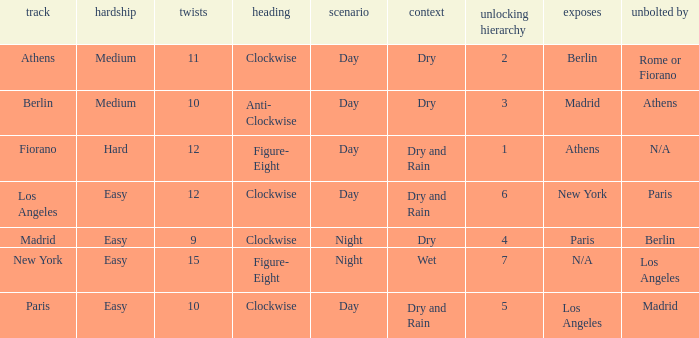What is the difficulty of the athens circuit? Medium. Give me the full table as a dictionary. {'header': ['track', 'hardship', 'twists', 'heading', 'scenario', 'context', 'unlocking hierarchy', 'exposes', 'unbolted by'], 'rows': [['Athens', 'Medium', '11', 'Clockwise', 'Day', 'Dry', '2', 'Berlin', 'Rome or Fiorano'], ['Berlin', 'Medium', '10', 'Anti- Clockwise', 'Day', 'Dry', '3', 'Madrid', 'Athens'], ['Fiorano', 'Hard', '12', 'Figure- Eight', 'Day', 'Dry and Rain', '1', 'Athens', 'N/A'], ['Los Angeles', 'Easy', '12', 'Clockwise', 'Day', 'Dry and Rain', '6', 'New York', 'Paris'], ['Madrid', 'Easy', '9', 'Clockwise', 'Night', 'Dry', '4', 'Paris', 'Berlin'], ['New York', 'Easy', '15', 'Figure- Eight', 'Night', 'Wet', '7', 'N/A', 'Los Angeles'], ['Paris', 'Easy', '10', 'Clockwise', 'Day', 'Dry and Rain', '5', 'Los Angeles', 'Madrid']]} 